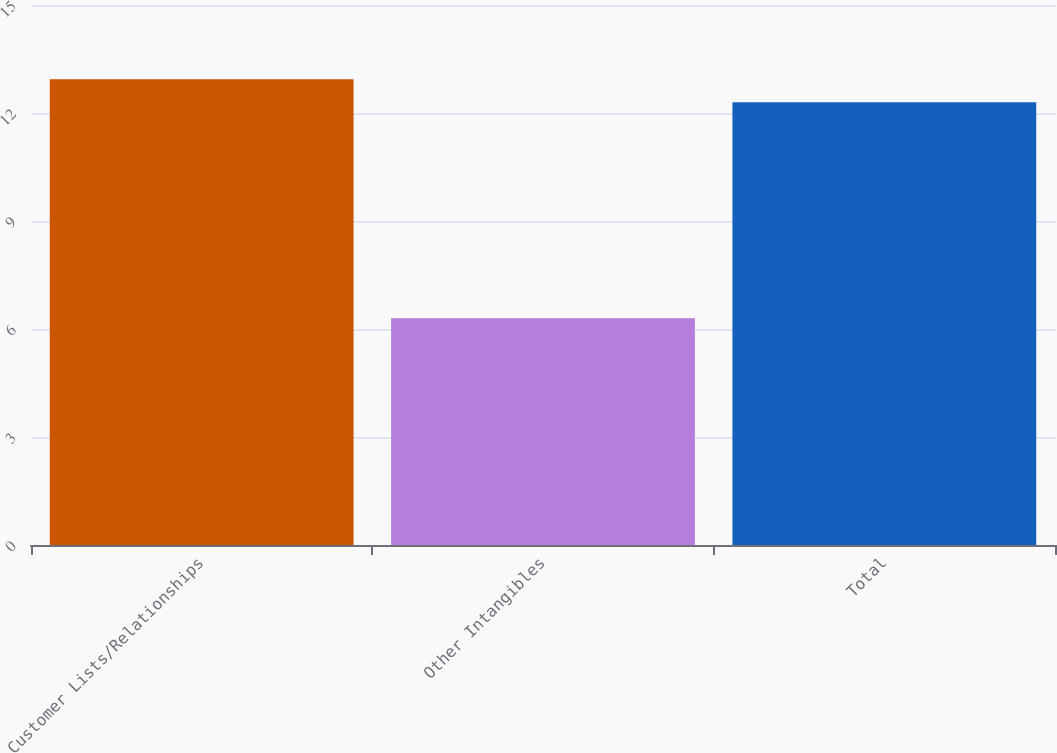Convert chart. <chart><loc_0><loc_0><loc_500><loc_500><bar_chart><fcel>Customer Lists/Relationships<fcel>Other Intangibles<fcel>Total<nl><fcel>12.94<fcel>6.3<fcel>12.3<nl></chart> 